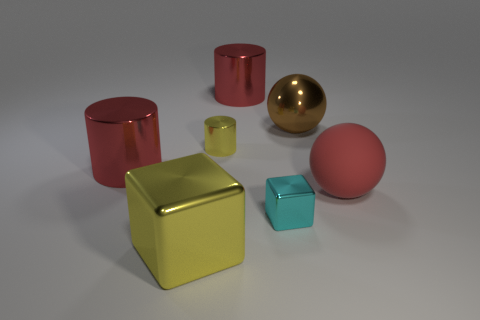Add 1 cyan metallic things. How many objects exist? 8 Subtract all balls. How many objects are left? 5 Subtract all big yellow metal blocks. Subtract all large yellow blocks. How many objects are left? 5 Add 7 big metal cylinders. How many big metal cylinders are left? 9 Add 4 large purple matte things. How many large purple matte things exist? 4 Subtract 0 green blocks. How many objects are left? 7 